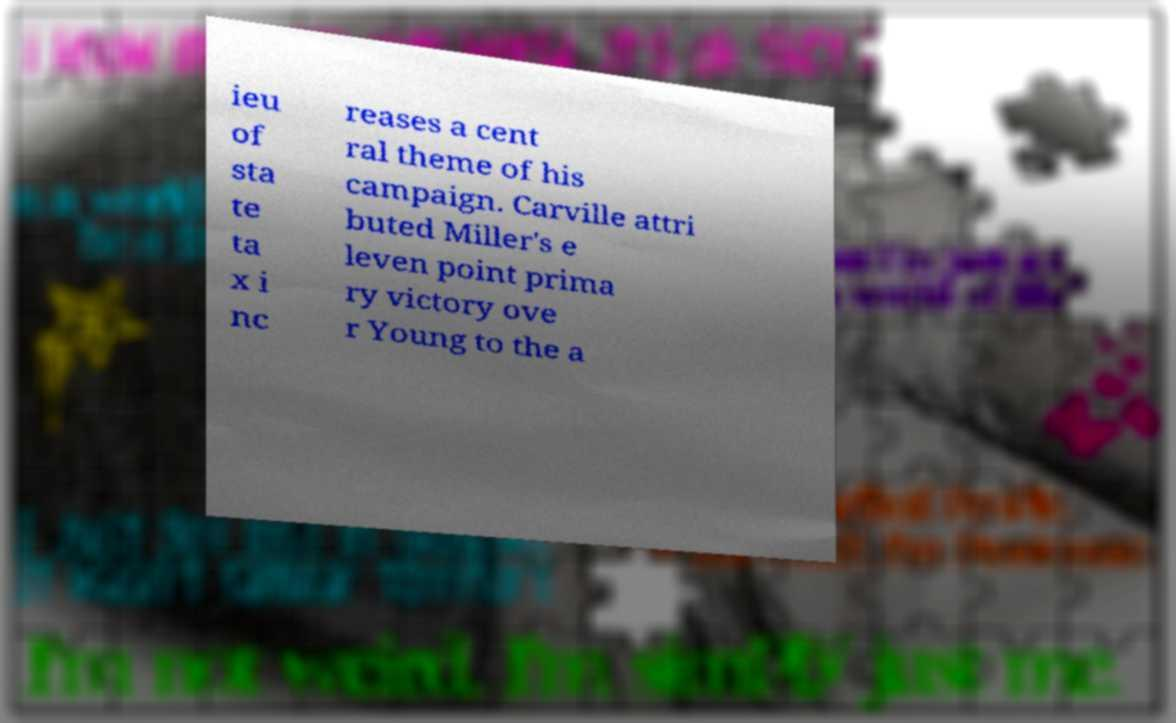I need the written content from this picture converted into text. Can you do that? ieu of sta te ta x i nc reases a cent ral theme of his campaign. Carville attri buted Miller's e leven point prima ry victory ove r Young to the a 